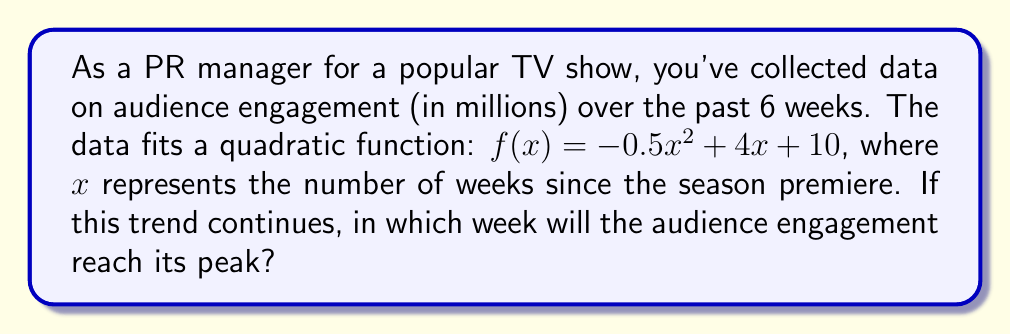Teach me how to tackle this problem. To find the week when audience engagement reaches its peak, we need to determine the vertex of the quadratic function. The vertex represents the maximum point of a parabola that opens downward (negative leading coefficient).

1) For a quadratic function in the form $f(x) = ax^2 + bx + c$, the x-coordinate of the vertex is given by $x = -\frac{b}{2a}$.

2) In our function $f(x) = -0.5x^2 + 4x + 10$:
   $a = -0.5$
   $b = 4$

3) Applying the formula:
   $x = -\frac{b}{2a} = -\frac{4}{2(-0.5)} = -\frac{4}{-1} = 4$

4) The x-coordinate of the vertex is 4, which represents 4 weeks after the season premiere.

5) To verify, we can calculate the engagement for weeks 3, 4, and 5:
   Week 3: $f(3) = -0.5(3)^2 + 4(3) + 10 = -4.5 + 12 + 10 = 17.5$ million
   Week 4: $f(4) = -0.5(4)^2 + 4(4) + 10 = -8 + 16 + 10 = 18$ million
   Week 5: $f(5) = -0.5(5)^2 + 4(5) + 10 = -12.5 + 20 + 10 = 17.5$ million

This confirms that week 4 has the highest engagement.
Answer: 4 weeks after the season premiere 